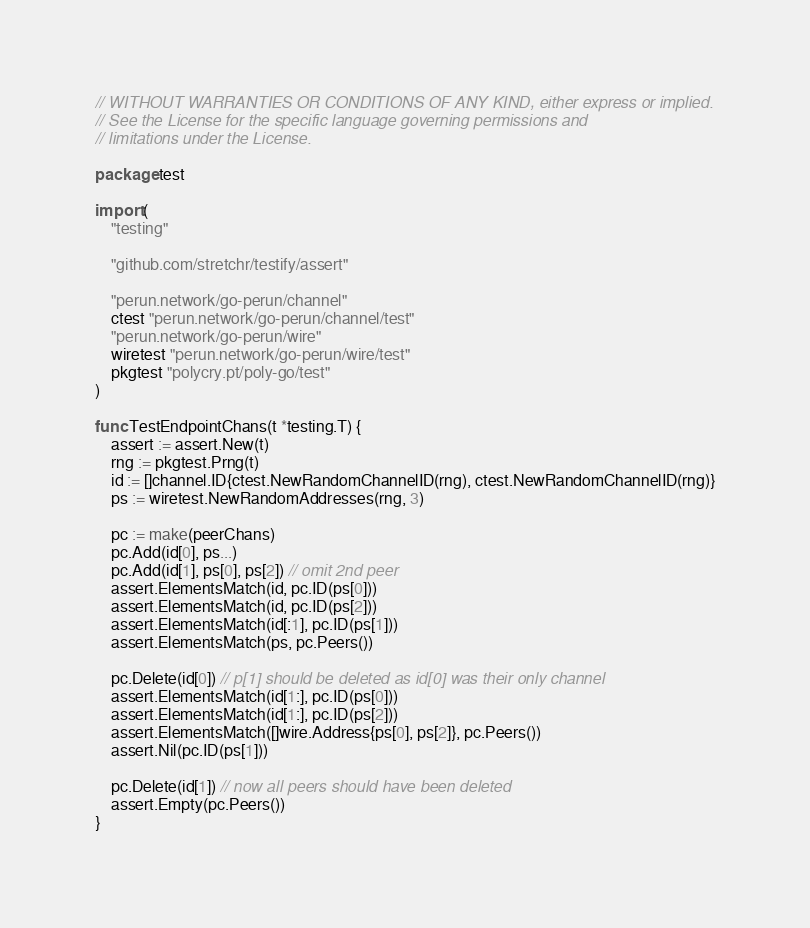Convert code to text. <code><loc_0><loc_0><loc_500><loc_500><_Go_>// WITHOUT WARRANTIES OR CONDITIONS OF ANY KIND, either express or implied.
// See the License for the specific language governing permissions and
// limitations under the License.

package test

import (
	"testing"

	"github.com/stretchr/testify/assert"

	"perun.network/go-perun/channel"
	ctest "perun.network/go-perun/channel/test"
	"perun.network/go-perun/wire"
	wiretest "perun.network/go-perun/wire/test"
	pkgtest "polycry.pt/poly-go/test"
)

func TestEndpointChans(t *testing.T) {
	assert := assert.New(t)
	rng := pkgtest.Prng(t)
	id := []channel.ID{ctest.NewRandomChannelID(rng), ctest.NewRandomChannelID(rng)}
	ps := wiretest.NewRandomAddresses(rng, 3)

	pc := make(peerChans)
	pc.Add(id[0], ps...)
	pc.Add(id[1], ps[0], ps[2]) // omit 2nd peer
	assert.ElementsMatch(id, pc.ID(ps[0]))
	assert.ElementsMatch(id, pc.ID(ps[2]))
	assert.ElementsMatch(id[:1], pc.ID(ps[1]))
	assert.ElementsMatch(ps, pc.Peers())

	pc.Delete(id[0]) // p[1] should be deleted as id[0] was their only channel
	assert.ElementsMatch(id[1:], pc.ID(ps[0]))
	assert.ElementsMatch(id[1:], pc.ID(ps[2]))
	assert.ElementsMatch([]wire.Address{ps[0], ps[2]}, pc.Peers())
	assert.Nil(pc.ID(ps[1]))

	pc.Delete(id[1]) // now all peers should have been deleted
	assert.Empty(pc.Peers())
}
</code> 